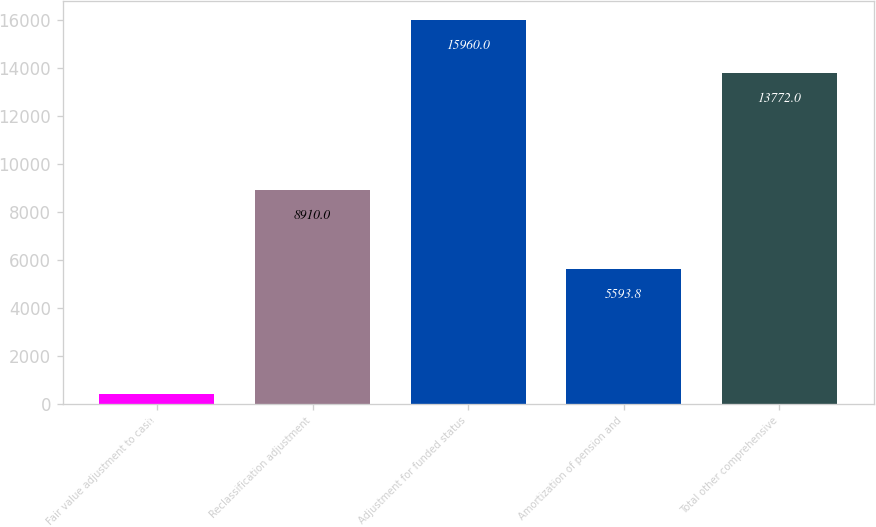<chart> <loc_0><loc_0><loc_500><loc_500><bar_chart><fcel>Fair value adjustment to cash<fcel>Reclassification adjustment<fcel>Adjustment for funded status<fcel>Amortization of pension and<fcel>Total other comprehensive<nl><fcel>401<fcel>8910<fcel>15960<fcel>5593.8<fcel>13772<nl></chart> 